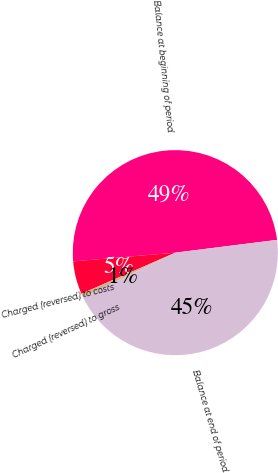Convert chart to OTSL. <chart><loc_0><loc_0><loc_500><loc_500><pie_chart><fcel>Balance at beginning of period<fcel>Charged (reversed) to costs<fcel>Charged (reversed) to gross<fcel>Balance at end of period<nl><fcel>49.37%<fcel>5.21%<fcel>0.63%<fcel>44.79%<nl></chart> 